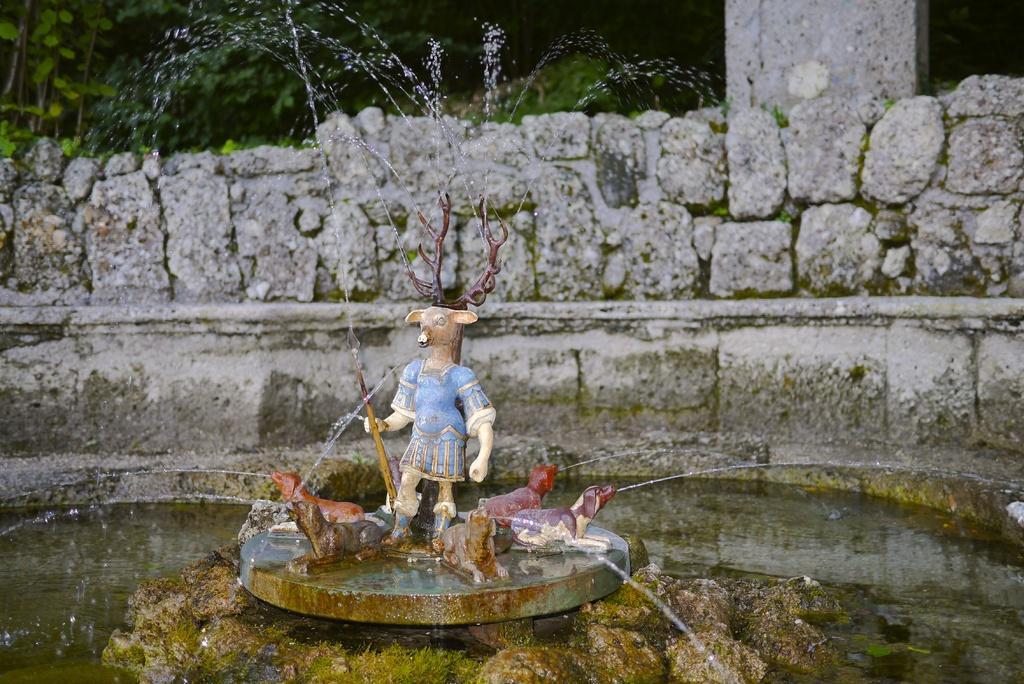Describe this image in one or two sentences. In this image we can see a statue and fountain. In the background, there is a stone wall, pillar and greenery. 